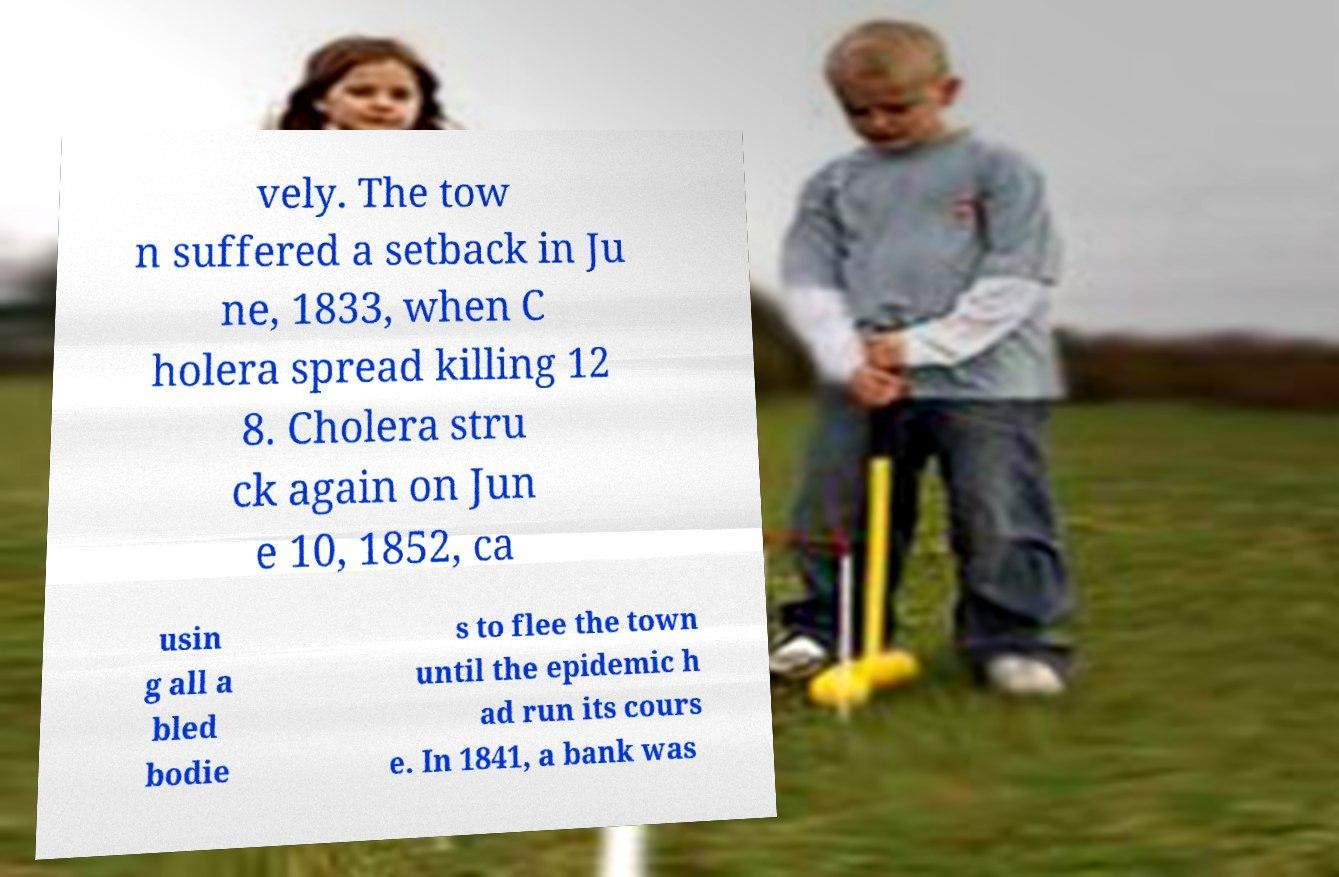Could you assist in decoding the text presented in this image and type it out clearly? vely. The tow n suffered a setback in Ju ne, 1833, when C holera spread killing 12 8. Cholera stru ck again on Jun e 10, 1852, ca usin g all a bled bodie s to flee the town until the epidemic h ad run its cours e. In 1841, a bank was 